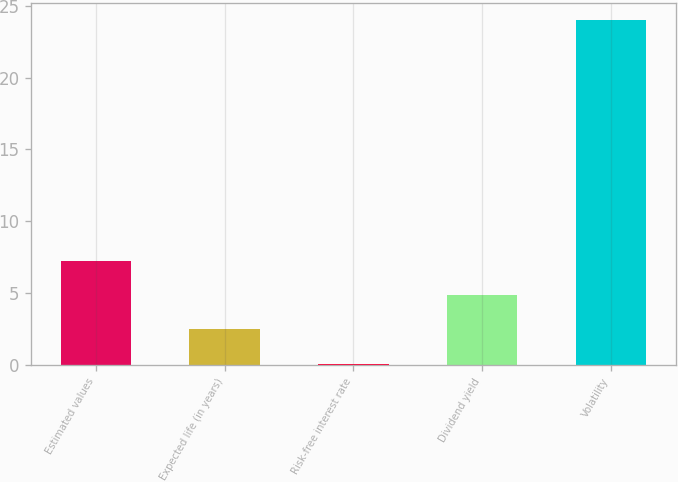Convert chart. <chart><loc_0><loc_0><loc_500><loc_500><bar_chart><fcel>Estimated values<fcel>Expected life (in years)<fcel>Risk-free interest rate<fcel>Dividend yield<fcel>Volatility<nl><fcel>7.27<fcel>2.49<fcel>0.1<fcel>4.88<fcel>24<nl></chart> 